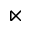<formula> <loc_0><loc_0><loc_500><loc_500>\ltimes</formula> 